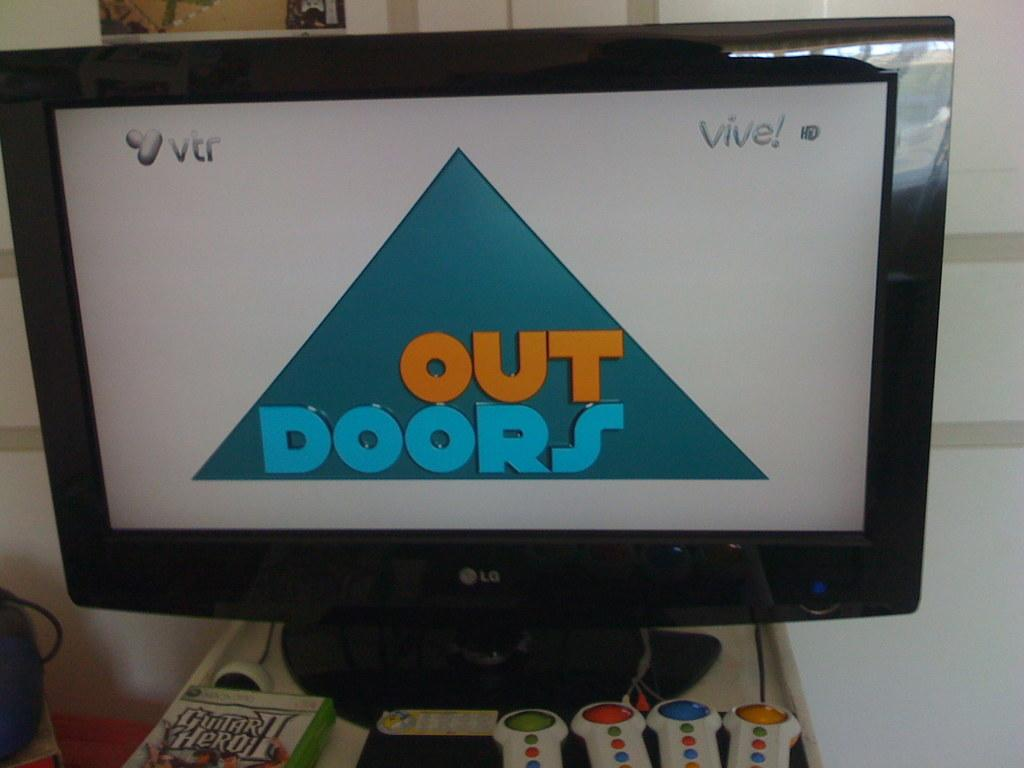<image>
Write a terse but informative summary of the picture. an lg screen that says 'out doors' on it 